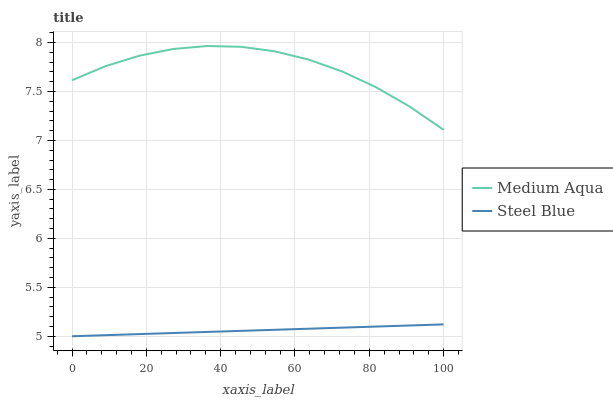Does Steel Blue have the maximum area under the curve?
Answer yes or no. No. Is Steel Blue the roughest?
Answer yes or no. No. Does Steel Blue have the highest value?
Answer yes or no. No. Is Steel Blue less than Medium Aqua?
Answer yes or no. Yes. Is Medium Aqua greater than Steel Blue?
Answer yes or no. Yes. Does Steel Blue intersect Medium Aqua?
Answer yes or no. No. 